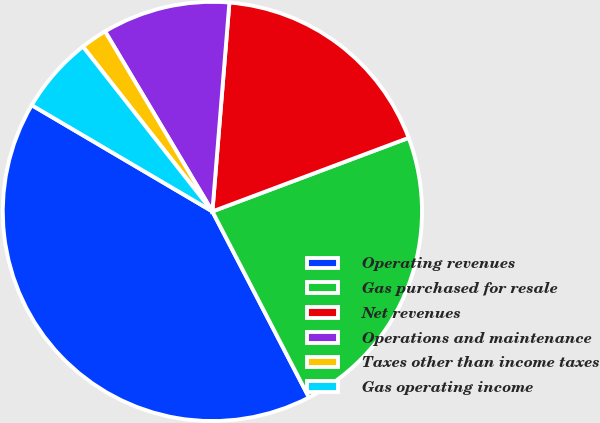<chart> <loc_0><loc_0><loc_500><loc_500><pie_chart><fcel>Operating revenues<fcel>Gas purchased for resale<fcel>Net revenues<fcel>Operations and maintenance<fcel>Taxes other than income taxes<fcel>Gas operating income<nl><fcel>41.09%<fcel>23.09%<fcel>18.0%<fcel>9.85%<fcel>2.04%<fcel>5.94%<nl></chart> 